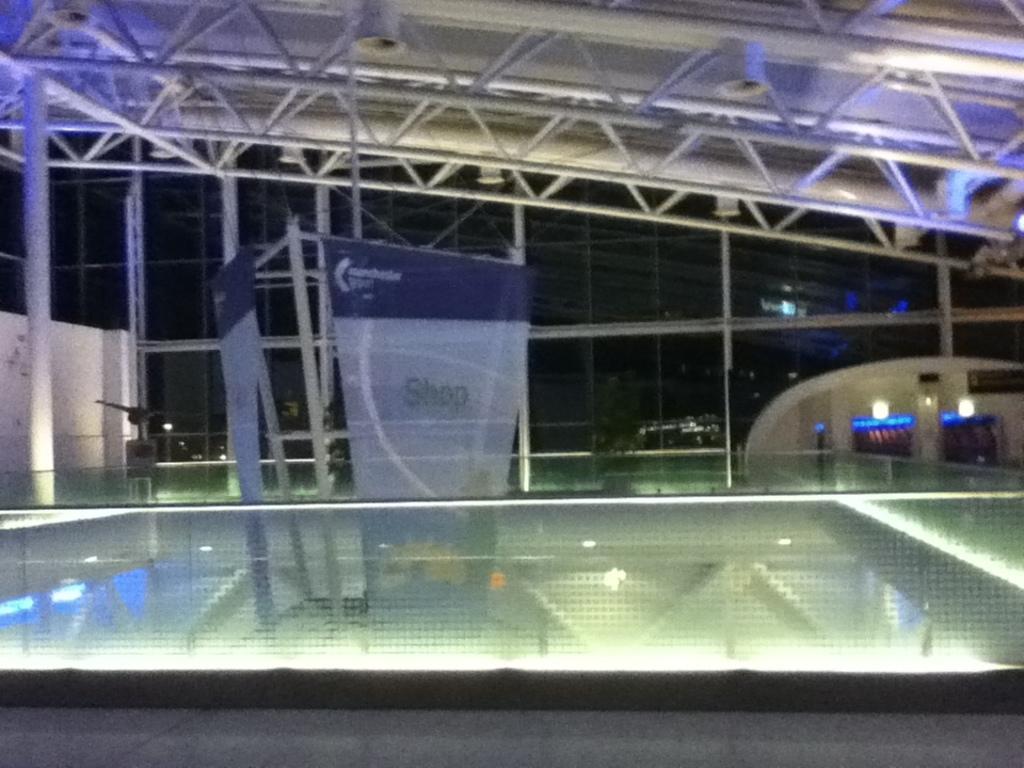Could you give a brief overview of what you see in this image? In this image there are two bannerś, there is wall made of glass, there are two lightś, there is wall, there is roof. 